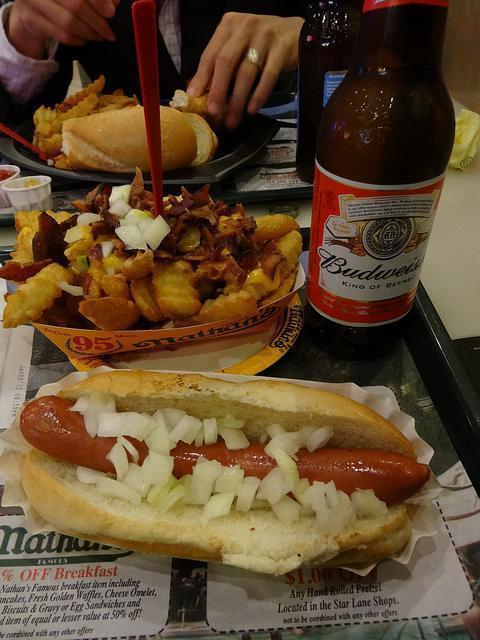Consuming which one of these items will make it dangerous to drive?
From the following four choices, select the correct answer to address the question.
Options: In box, in bottle, on plate, in bun. In bottle. 